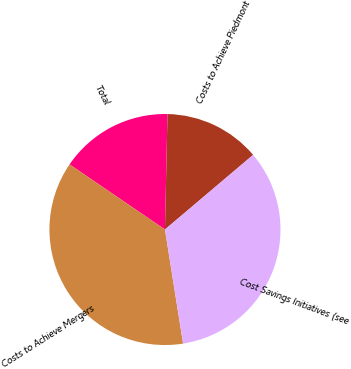Convert chart to OTSL. <chart><loc_0><loc_0><loc_500><loc_500><pie_chart><fcel>Costs to Achieve Piedmont<fcel>Total<fcel>Costs to Achieve Mergers<fcel>Cost Savings Initiatives (see<nl><fcel>13.47%<fcel>15.82%<fcel>37.04%<fcel>33.67%<nl></chart> 